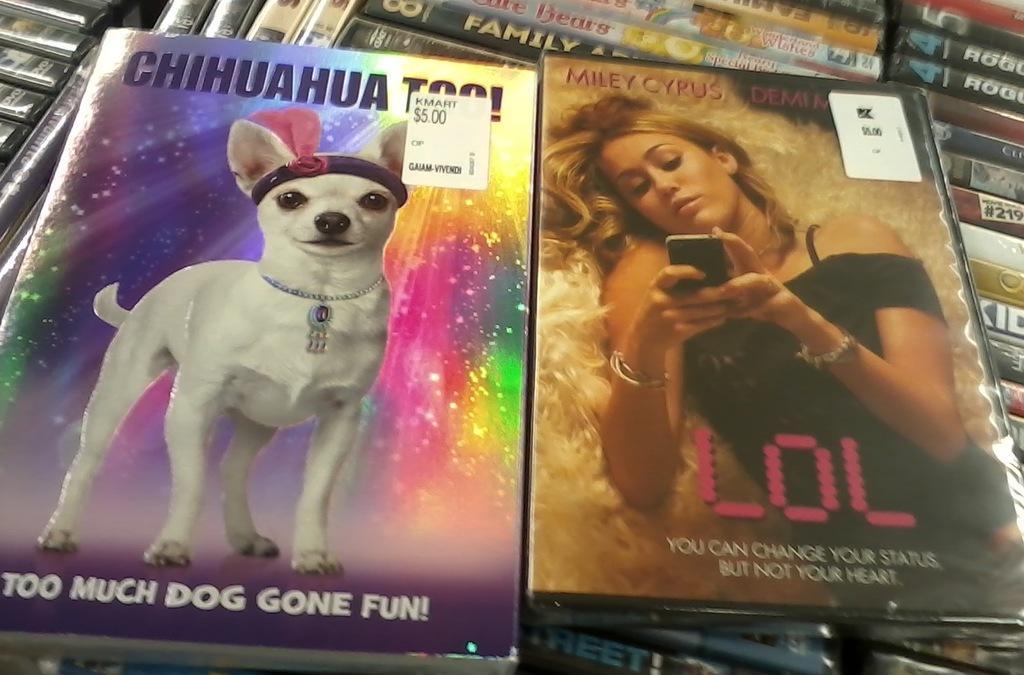Can you describe this image briefly? In this picture we can see stickers, posters and on these posters we can see a dog, woman, mobile and some text and in the background we can see books. 